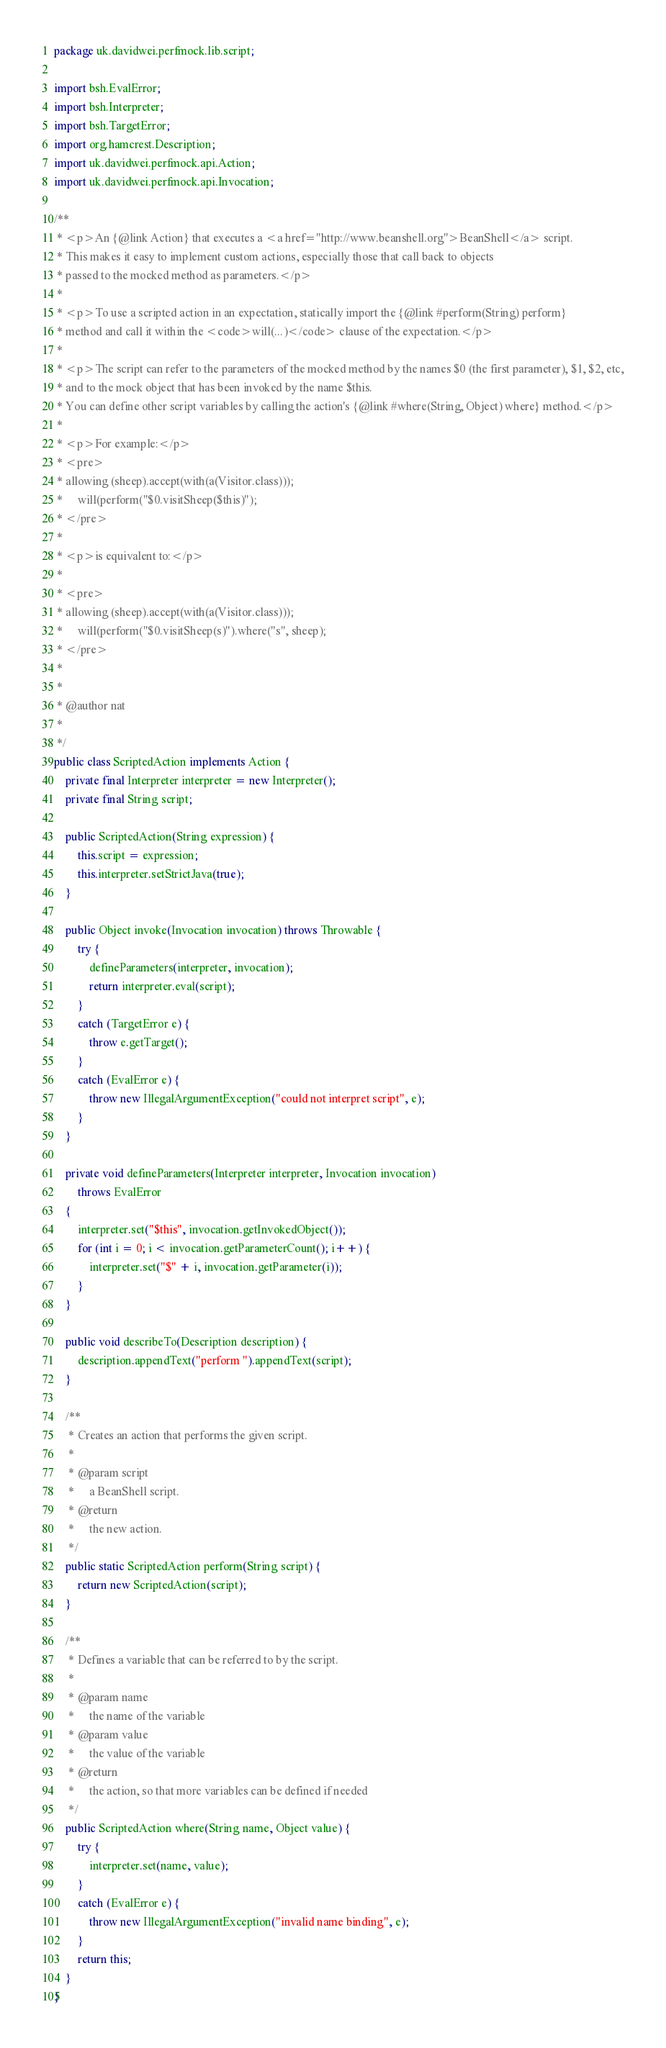<code> <loc_0><loc_0><loc_500><loc_500><_Java_>package uk.davidwei.perfmock.lib.script;

import bsh.EvalError;
import bsh.Interpreter;
import bsh.TargetError;
import org.hamcrest.Description;
import uk.davidwei.perfmock.api.Action;
import uk.davidwei.perfmock.api.Invocation;

/** 
 * <p>An {@link Action} that executes a <a href="http://www.beanshell.org">BeanShell</a> script.
 * This makes it easy to implement custom actions, especially those that call back to objects 
 * passed to the mocked method as parameters.</p>
 * 
 * <p>To use a scripted action in an expectation, statically import the {@link #perform(String) perform}
 * method and call it within the <code>will(...)</code> clause of the expectation.</p>
 * 
 * <p>The script can refer to the parameters of the mocked method by the names $0 (the first parameter), $1, $2, etc,
 * and to the mock object that has been invoked by the name $this.
 * You can define other script variables by calling the action's {@link #where(String, Object) where} method.</p>
 * 
 * <p>For example:</p>
 * <pre>
 * allowing (sheep).accept(with(a(Visitor.class))); 
 *     will(perform("$0.visitSheep($this)");
 * </pre>
 * 
 * <p>is equivalent to:</p>
 * 
 * <pre>
 * allowing (sheep).accept(with(a(Visitor.class))); 
 *     will(perform("$0.visitSheep(s)").where("s", sheep);
 * </pre>
 * 
 * 
 * @author nat
 *
 */
public class ScriptedAction implements Action {
    private final Interpreter interpreter = new Interpreter();
    private final String script;

    public ScriptedAction(String expression) {
        this.script = expression;
        this.interpreter.setStrictJava(true);
    }

    public Object invoke(Invocation invocation) throws Throwable {
        try {
            defineParameters(interpreter, invocation);
            return interpreter.eval(script);
        }
        catch (TargetError e) {
            throw e.getTarget();
        }
        catch (EvalError e) {
            throw new IllegalArgumentException("could not interpret script", e);
        }
    }
    
    private void defineParameters(Interpreter interpreter, Invocation invocation) 
        throws EvalError 
    {
        interpreter.set("$this", invocation.getInvokedObject());
        for (int i = 0; i < invocation.getParameterCount(); i++) {
            interpreter.set("$" + i, invocation.getParameter(i));
        }
    }

    public void describeTo(Description description) {
        description.appendText("perform ").appendText(script);
    }
    
    /**
     * Creates an action that performs the given script.
     * 
     * @param script
     *     a BeanShell script.
     * @return
     *     the new action.
     */
    public static ScriptedAction perform(String script) {
        return new ScriptedAction(script);
    }
    
    /**
     * Defines a variable that can be referred to by the script.
     * 
     * @param name
     *     the name of the variable
     * @param value
     *     the value of the variable
     * @return
     *     the action, so that more variables can be defined if needed
     */
    public ScriptedAction where(String name, Object value) {
        try {
            interpreter.set(name, value);
        }
        catch (EvalError e) {
            throw new IllegalArgumentException("invalid name binding", e);
        }
        return this;
    }
}
</code> 